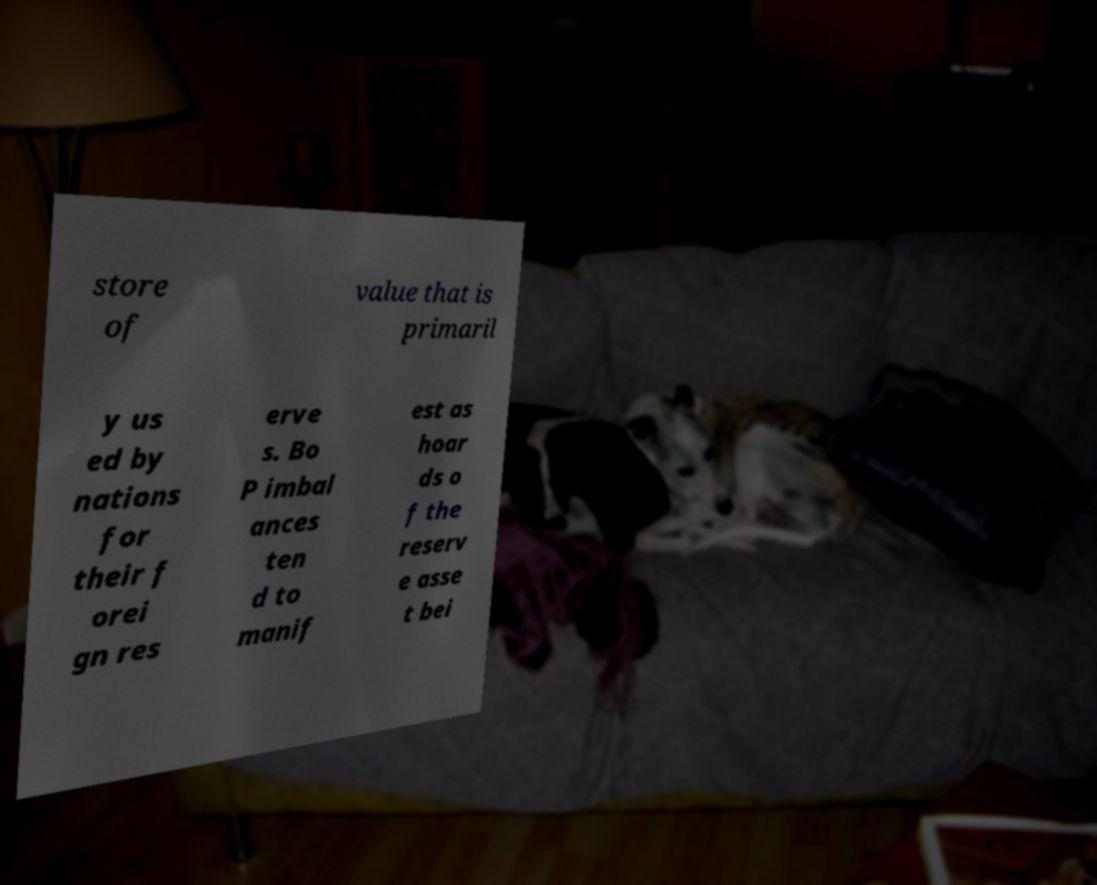There's text embedded in this image that I need extracted. Can you transcribe it verbatim? store of value that is primaril y us ed by nations for their f orei gn res erve s. Bo P imbal ances ten d to manif est as hoar ds o f the reserv e asse t bei 